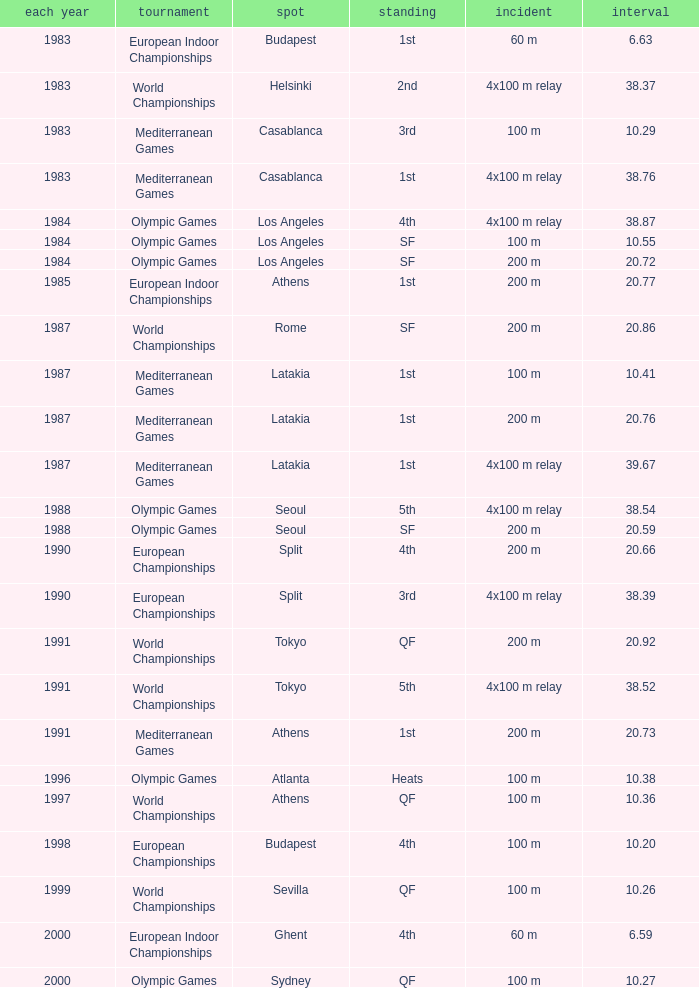What is the greatest Time with a Year of 1991, and Event of 4x100 m relay? 38.52. 